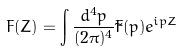<formula> <loc_0><loc_0><loc_500><loc_500>F ( Z ) = \int \frac { d ^ { 4 } p } { ( 2 \pi ) ^ { 4 } } \tilde { F } ( p ) e ^ { i p Z }</formula> 